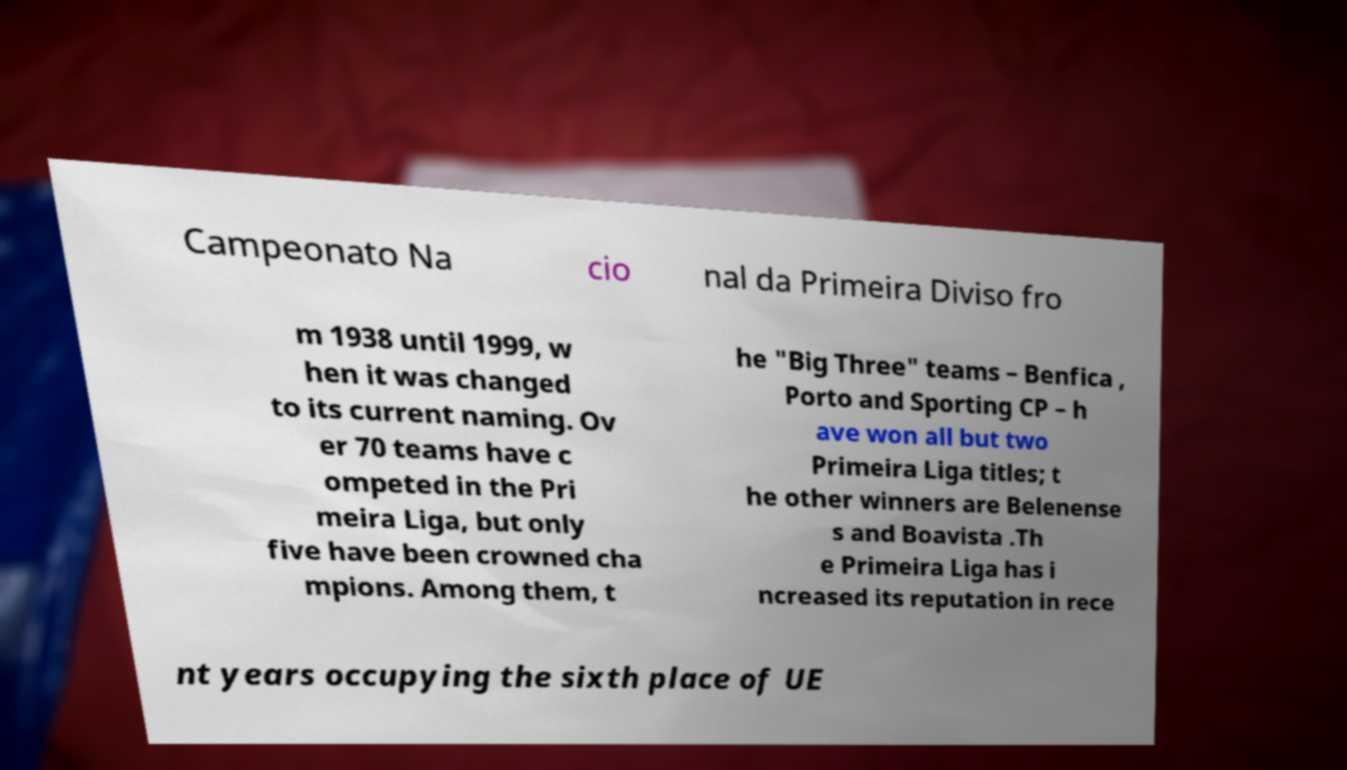Can you read and provide the text displayed in the image?This photo seems to have some interesting text. Can you extract and type it out for me? Campeonato Na cio nal da Primeira Diviso fro m 1938 until 1999, w hen it was changed to its current naming. Ov er 70 teams have c ompeted in the Pri meira Liga, but only five have been crowned cha mpions. Among them, t he "Big Three" teams – Benfica , Porto and Sporting CP – h ave won all but two Primeira Liga titles; t he other winners are Belenense s and Boavista .Th e Primeira Liga has i ncreased its reputation in rece nt years occupying the sixth place of UE 